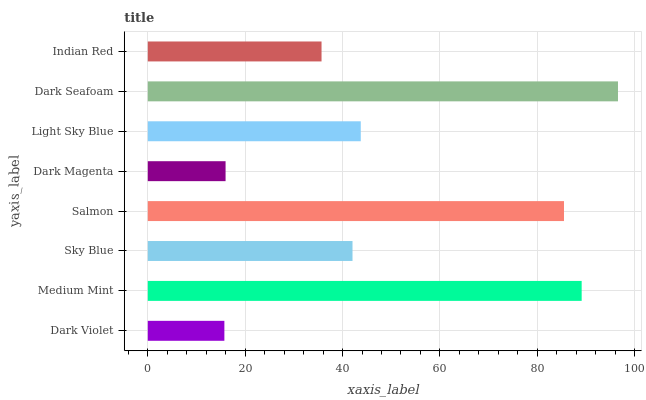Is Dark Violet the minimum?
Answer yes or no. Yes. Is Dark Seafoam the maximum?
Answer yes or no. Yes. Is Medium Mint the minimum?
Answer yes or no. No. Is Medium Mint the maximum?
Answer yes or no. No. Is Medium Mint greater than Dark Violet?
Answer yes or no. Yes. Is Dark Violet less than Medium Mint?
Answer yes or no. Yes. Is Dark Violet greater than Medium Mint?
Answer yes or no. No. Is Medium Mint less than Dark Violet?
Answer yes or no. No. Is Light Sky Blue the high median?
Answer yes or no. Yes. Is Sky Blue the low median?
Answer yes or no. Yes. Is Dark Violet the high median?
Answer yes or no. No. Is Indian Red the low median?
Answer yes or no. No. 